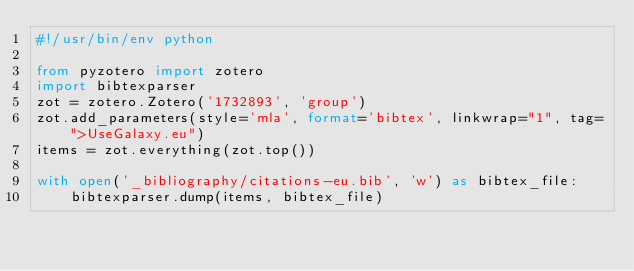Convert code to text. <code><loc_0><loc_0><loc_500><loc_500><_Python_>#!/usr/bin/env python

from pyzotero import zotero
import bibtexparser
zot = zotero.Zotero('1732893', 'group')
zot.add_parameters(style='mla', format='bibtex', linkwrap="1", tag=">UseGalaxy.eu")
items = zot.everything(zot.top())

with open('_bibliography/citations-eu.bib', 'w') as bibtex_file:
    bibtexparser.dump(items, bibtex_file)

</code> 